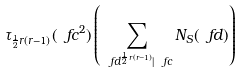Convert formula to latex. <formula><loc_0><loc_0><loc_500><loc_500>\tau _ { \frac { 1 } { 2 } r ( r - 1 ) } ( \ f c ^ { 2 } ) \left ( \sum _ { \ f d ^ { \frac { 1 } { 2 } r ( r - 1 ) } | \ f c } N _ { S } ( \ f d ) \right )</formula> 